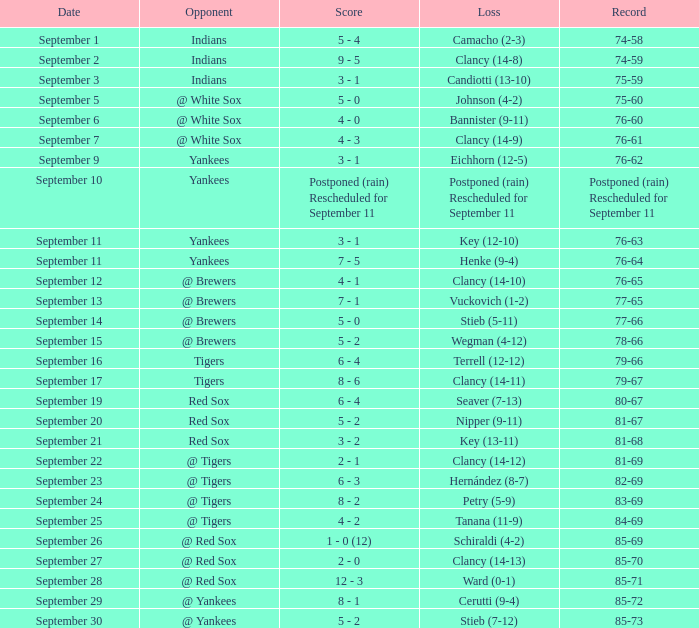What was the date of the game when their record was 84-69? September 25. 